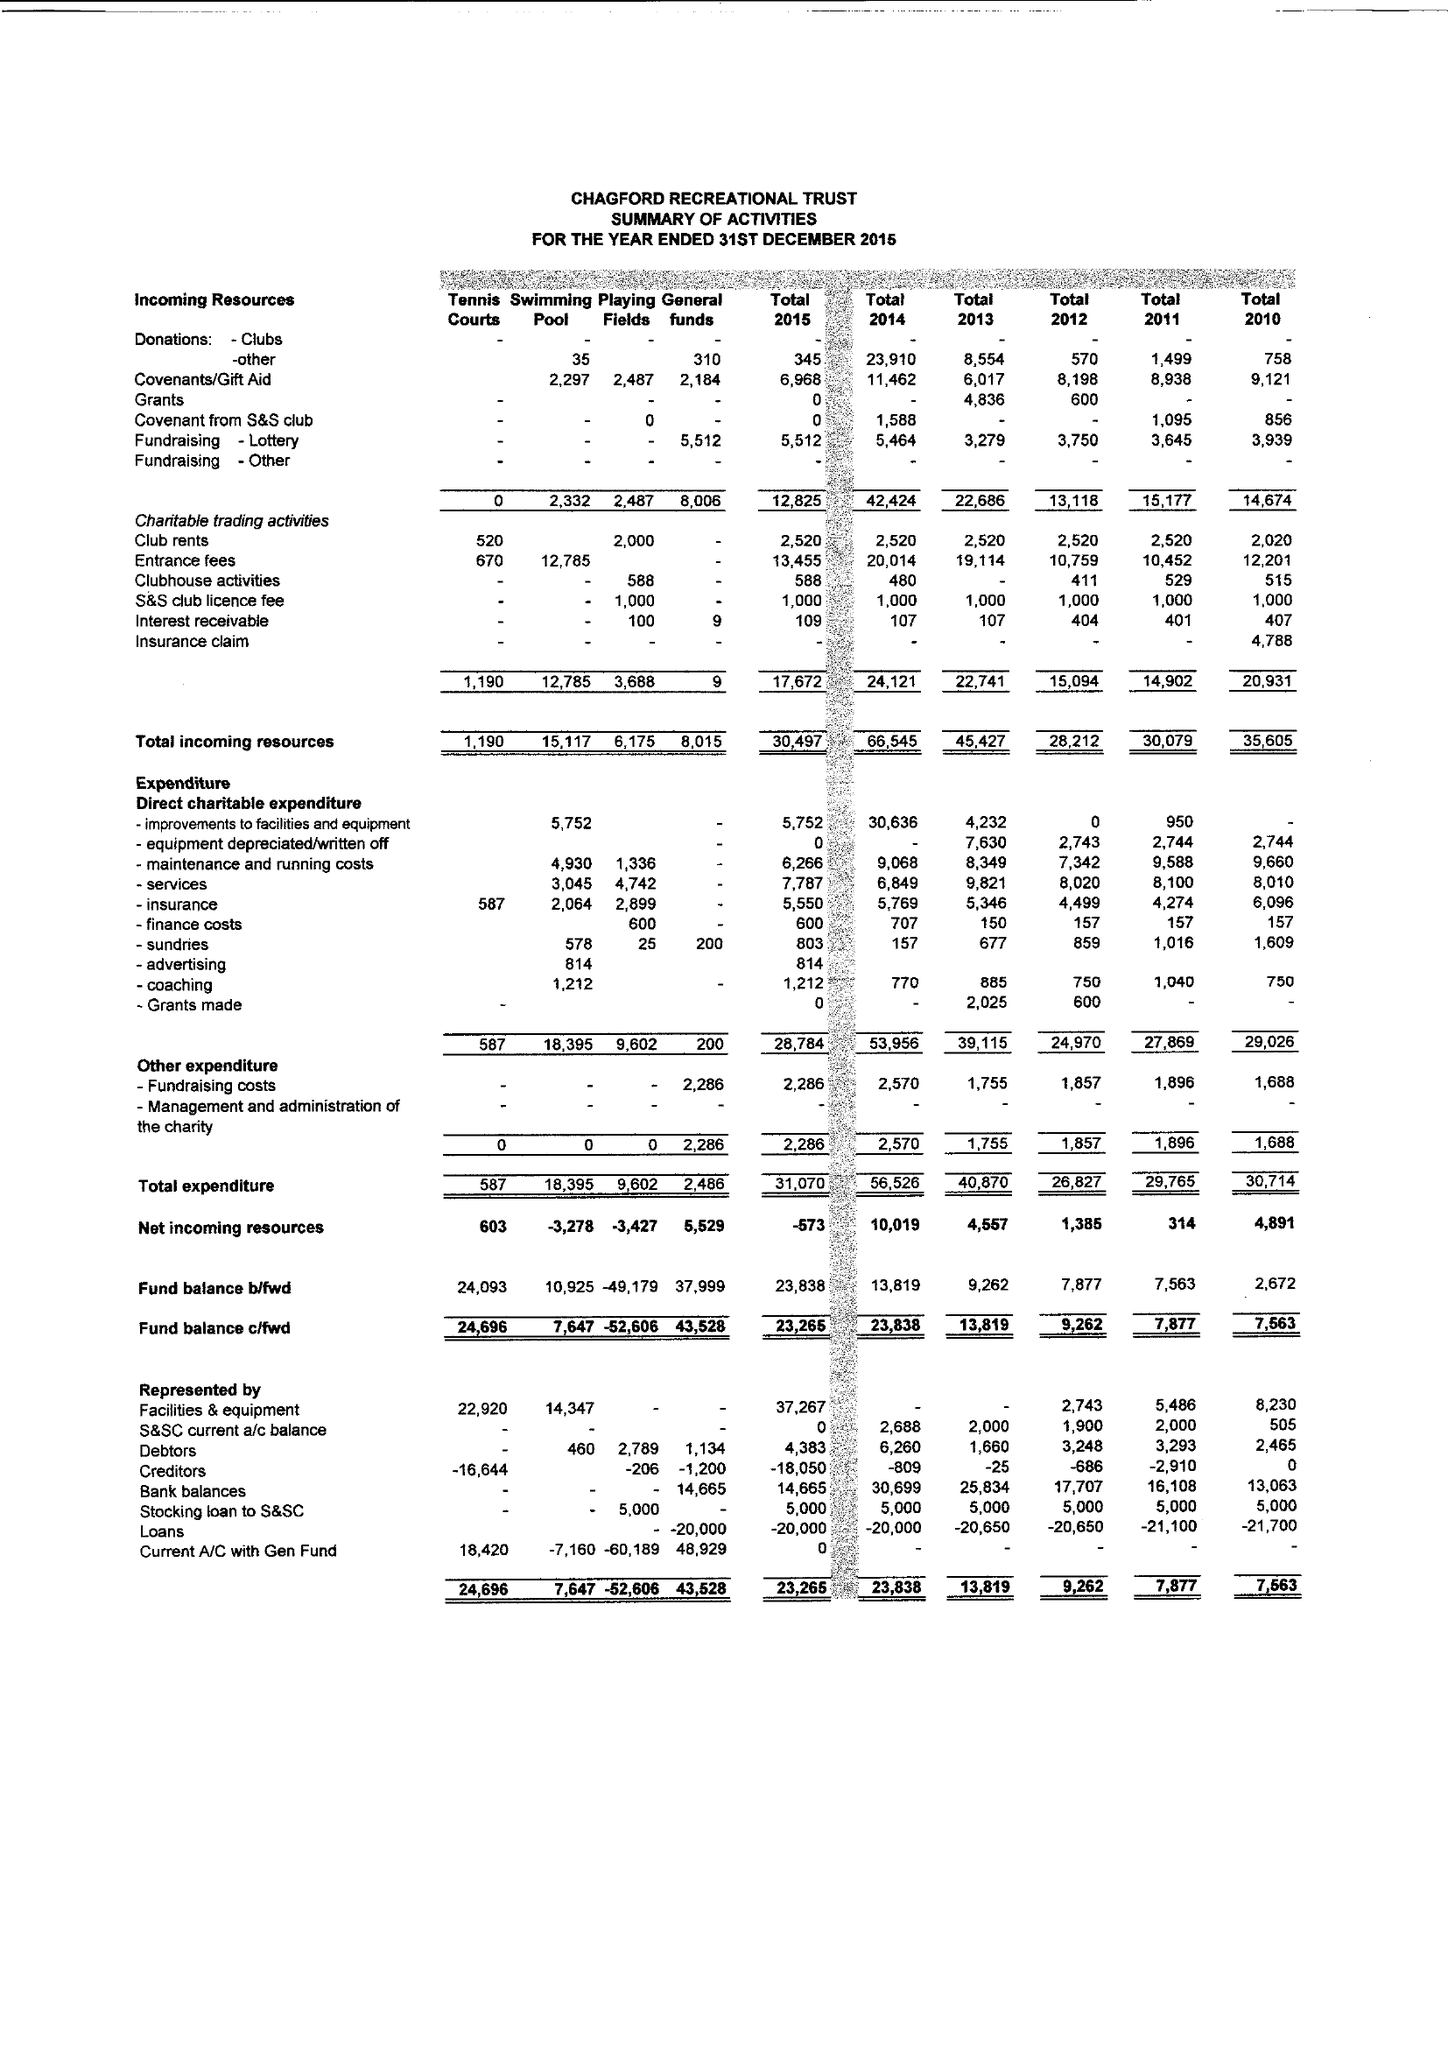What is the value for the address__street_line?
Answer the question using a single word or phrase. SANDY PARK 